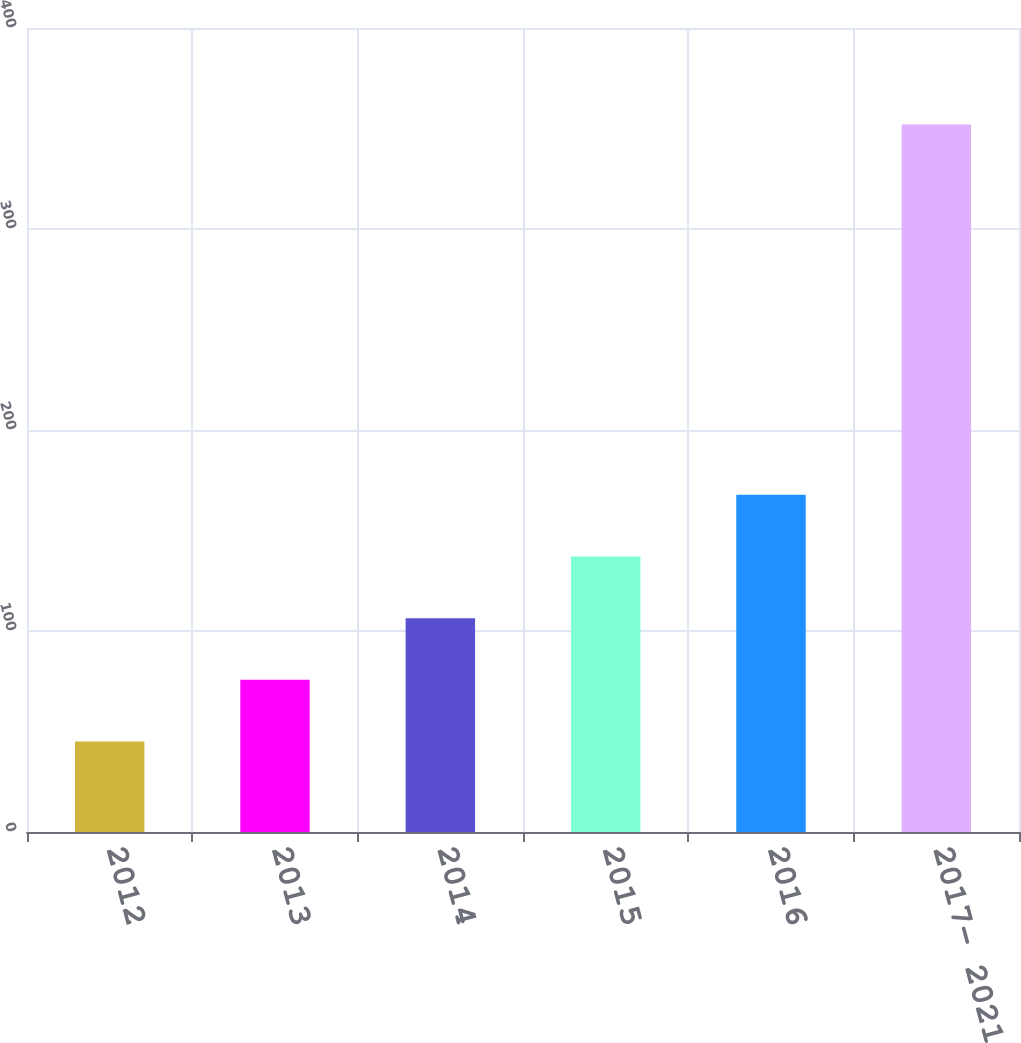<chart> <loc_0><loc_0><loc_500><loc_500><bar_chart><fcel>2012<fcel>2013<fcel>2014<fcel>2015<fcel>2016<fcel>2017- 2021<nl><fcel>45<fcel>75.7<fcel>106.4<fcel>137.1<fcel>167.8<fcel>352<nl></chart> 